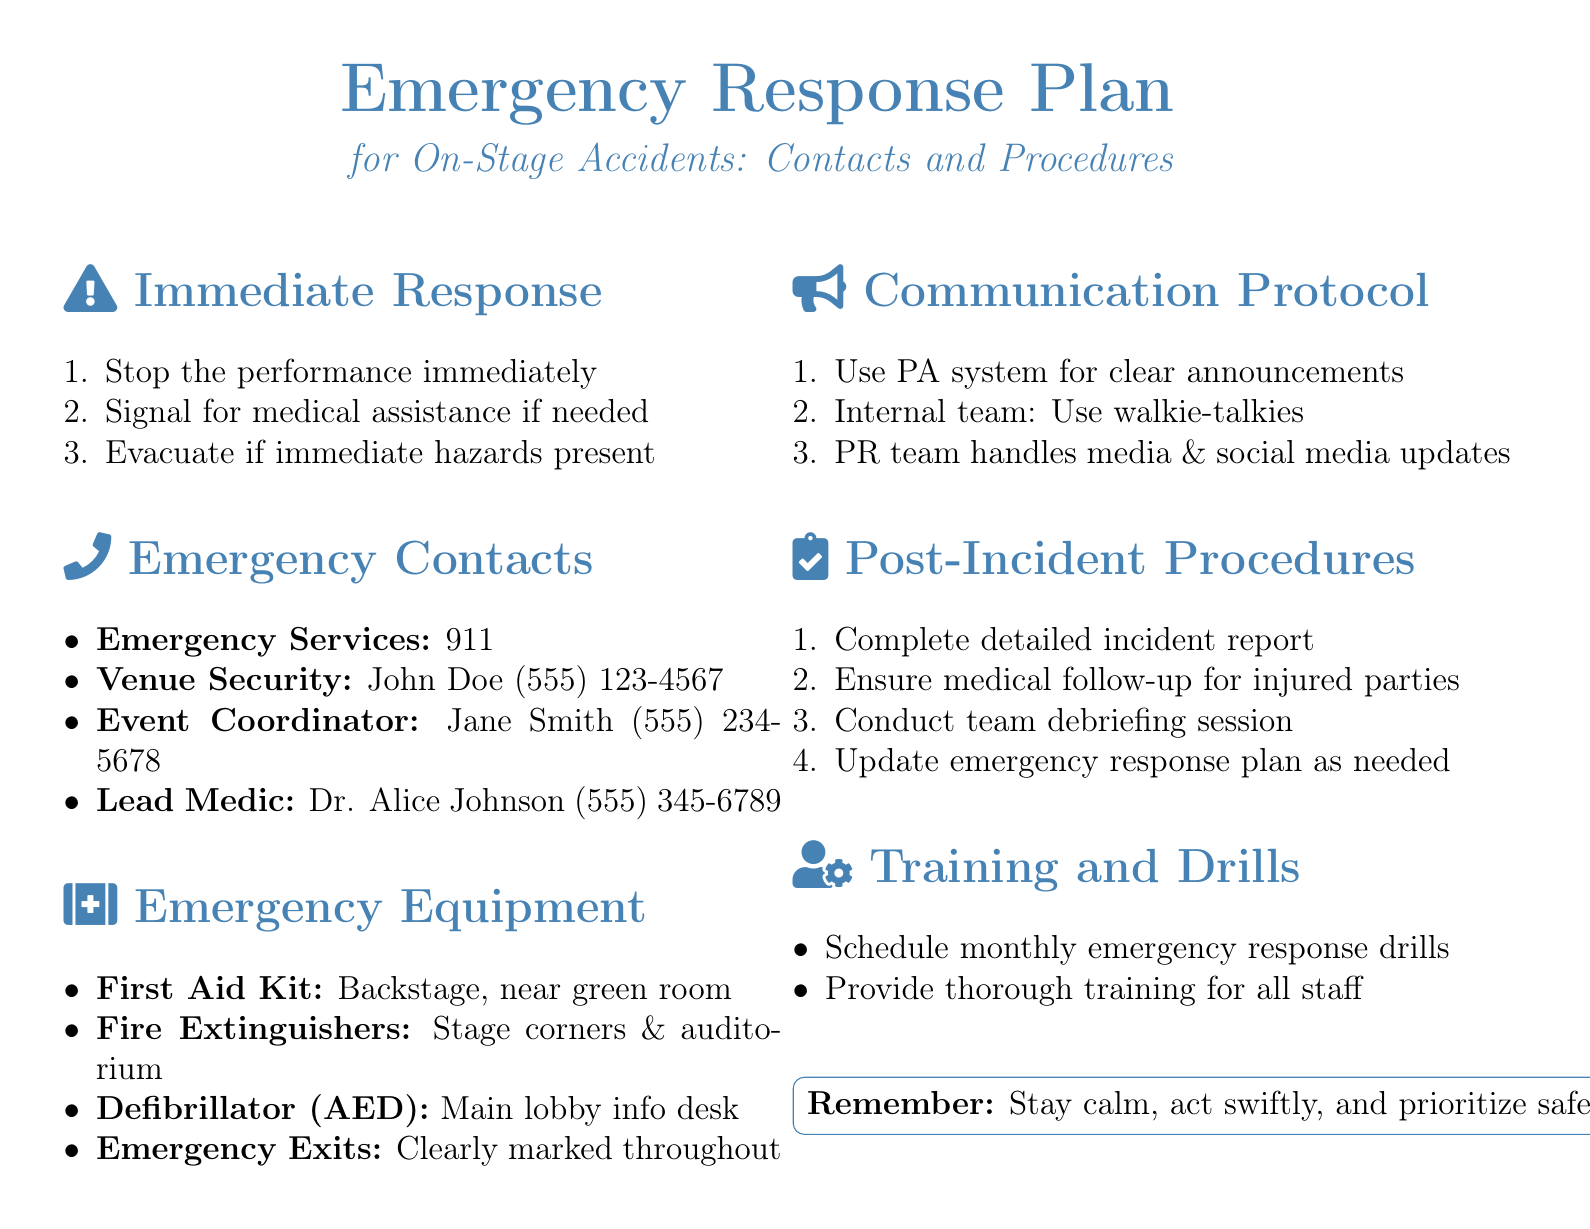What should be done immediately during an on-stage accident? The document outlines three immediate response actions to take during an on-stage accident.
Answer: Stop the performance immediately Who is the lead medic mentioned in the document? The document lists specific emergency contacts, including the lead medic.
Answer: Dr. Alice Johnson What phone number is provided for venue security? Venue security contact details include a name and phone number in the document.
Answer: (555) 123-4567 Where is the first aid kit located? The document specifies the location of several emergency equipment items, including the first aid kit.
Answer: Backstage, near green room What communication tool should be used by the internal team? The document mentions specific communication protocols for the internal team during an emergency.
Answer: Walkie-talkies What action is suggested after an incident has occurred? The document lists four post-incident procedures, one of which is to complete a specific report.
Answer: Complete detailed incident report How often should emergency response drills be scheduled? The document recommends a specific frequency for drills in the training section.
Answer: Monthly What priority is emphasized for response in the emergency plan? The document concludes with a box that emphasizes a key principle for responding to emergencies.
Answer: Prioritize safety at all times 